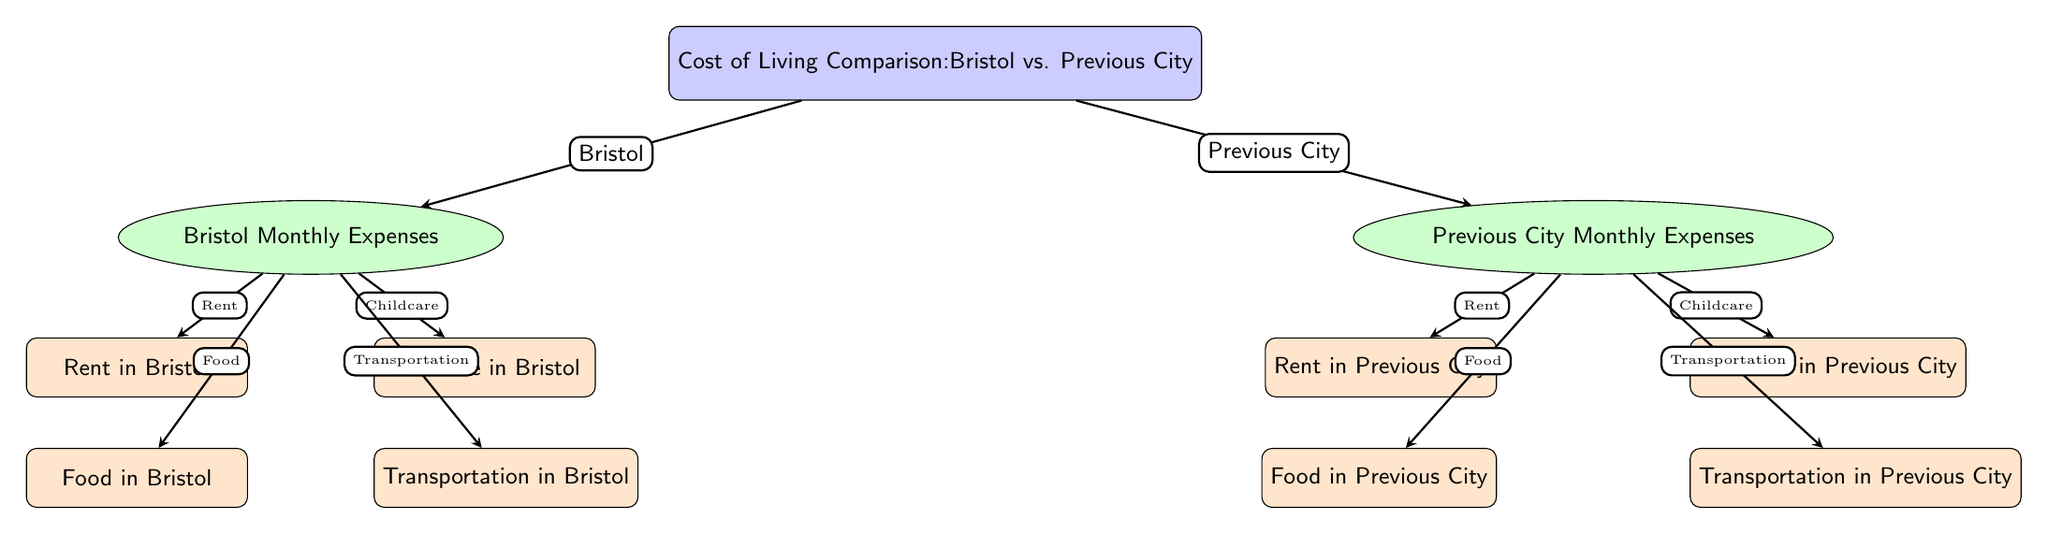What are the two main categories presented in the diagram? The diagram shows two main categories: Monthly Expenses for Bristol and Monthly Expenses for Previous City. These categories are displayed as nodes branching out from the main comparison node.
Answer: Bristol Monthly Expenses, Previous City Monthly Expenses How many expense types are listed for each city? The diagram lists four expense types for each city: Rent, Food, Childcare, and Transportation. Each of these expense types is represented by a node under the respective city node.
Answer: Four Which city's rent expense is displayed first in the diagram? The rent expense for Bristol is displayed first, as it is positioned higher in the hierarchy under the Bristol Monthly Expenses node, compared to the rent expense for the Previous City.
Answer: Bristol What does the arrow from the main node to the Bristol node indicate? The arrow indicates the direction of focus towards Bristol's monthly expenses in the context of the overall cost of living comparison, showing that it is a specific area of comparison from the main node.
Answer: Focus on Bristol's monthly expenses Compare the arrangement of expense types between the two cities. The arrangement is similar for both cities; both have the same four expense types listed (Rent, Food, Childcare, Transportation) positioned in the same order relative to their respective city nodes, indicating a direct comparison format.
Answer: Similar arrangement What relationship does the arrow create between the expense type nodes and their respective city nodes? The arrow establishes a direct relationship denoting that the expense types are specific aspects of the overall monthly expenses for each city, clarifying that each type contributes to the total living costs in that city.
Answer: Specific expenses of monthly costs Which node represents the overall cost of living comparison? The main node at the top of the diagram represents the overall cost of living comparison, serving as the starting point for the branches that lead to Bristol and Previous City.
Answer: Cost of Living Comparison Which type of diagram is this categorized under? This diagram is categorized as a Social Science Diagram, as it visually compares living costs in two different cities, focusing on social economic factors relevant to individuals, especially families.
Answer: Social Science Diagram 